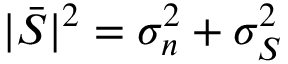Convert formula to latex. <formula><loc_0><loc_0><loc_500><loc_500>| \bar { S } | ^ { 2 } = \sigma _ { n } ^ { 2 } + \sigma _ { S } ^ { 2 }</formula> 